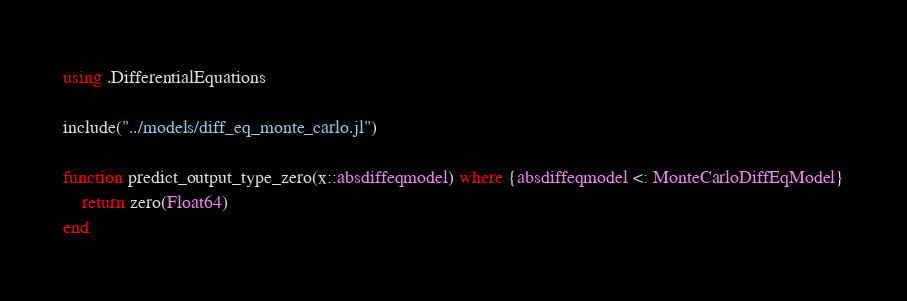Convert code to text. <code><loc_0><loc_0><loc_500><loc_500><_Julia_>using .DifferentialEquations

include("../models/diff_eq_monte_carlo.jl")

function predict_output_type_zero(x::absdiffeqmodel) where {absdiffeqmodel <: MonteCarloDiffEqModel}
    return zero(Float64)
end
</code> 